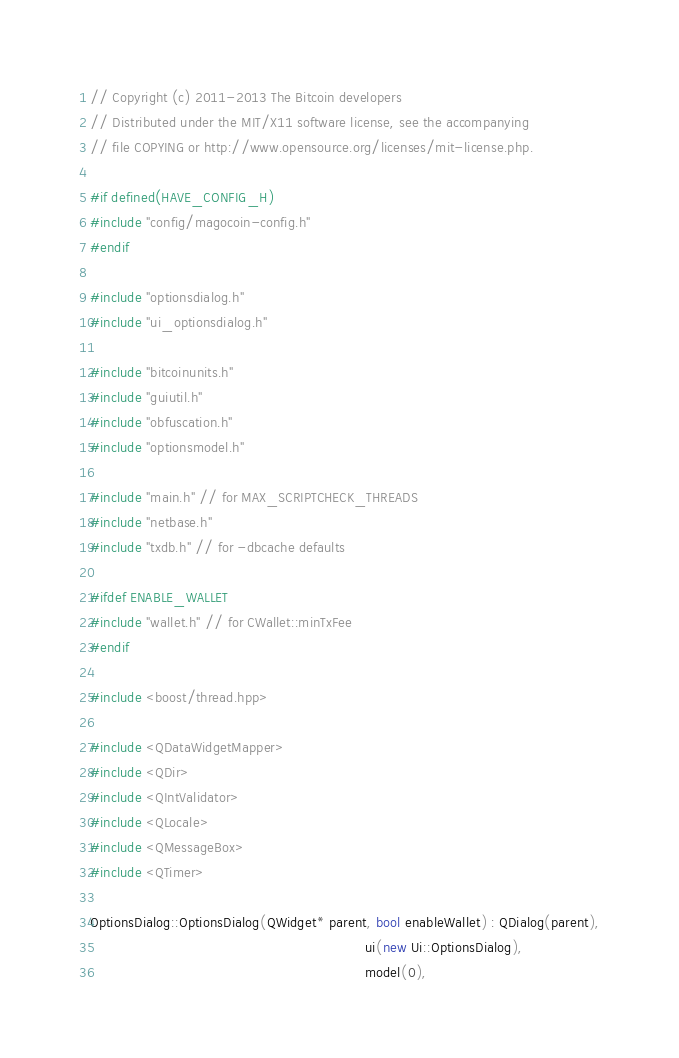Convert code to text. <code><loc_0><loc_0><loc_500><loc_500><_C++_>// Copyright (c) 2011-2013 The Bitcoin developers
// Distributed under the MIT/X11 software license, see the accompanying
// file COPYING or http://www.opensource.org/licenses/mit-license.php.

#if defined(HAVE_CONFIG_H)
#include "config/magocoin-config.h"
#endif

#include "optionsdialog.h"
#include "ui_optionsdialog.h"

#include "bitcoinunits.h"
#include "guiutil.h"
#include "obfuscation.h"
#include "optionsmodel.h"

#include "main.h" // for MAX_SCRIPTCHECK_THREADS
#include "netbase.h"
#include "txdb.h" // for -dbcache defaults

#ifdef ENABLE_WALLET
#include "wallet.h" // for CWallet::minTxFee
#endif

#include <boost/thread.hpp>

#include <QDataWidgetMapper>
#include <QDir>
#include <QIntValidator>
#include <QLocale>
#include <QMessageBox>
#include <QTimer>

OptionsDialog::OptionsDialog(QWidget* parent, bool enableWallet) : QDialog(parent),
                                                                   ui(new Ui::OptionsDialog),
                                                                   model(0),</code> 